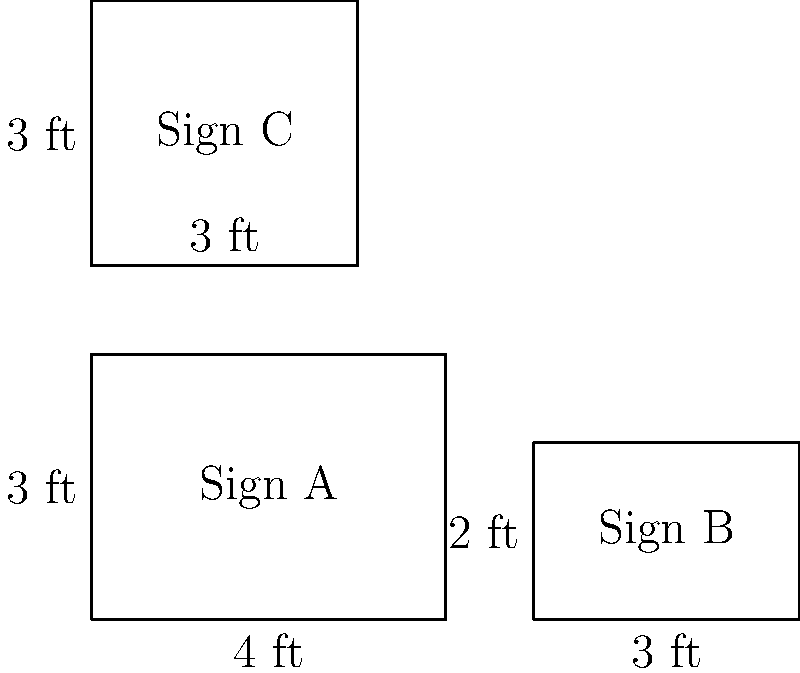You're organizing a campaign to promote traditional family values. You have three rectangular campaign signs with the following dimensions:

Sign A: 4 ft x 3 ft
Sign B: 3 ft x 2 ft
Sign C: 3 ft x 3 ft

What is the total area of all three signs combined? Express your answer in square feet. To find the total area of all three signs, we need to calculate the area of each sign individually and then sum them up.

1. Calculate the area of Sign A:
   $$ \text{Area}_A = \text{length} \times \text{width} = 4 \text{ ft} \times 3 \text{ ft} = 12 \text{ sq ft} $$

2. Calculate the area of Sign B:
   $$ \text{Area}_B = \text{length} \times \text{width} = 3 \text{ ft} \times 2 \text{ ft} = 6 \text{ sq ft} $$

3. Calculate the area of Sign C:
   $$ \text{Area}_C = \text{length} \times \text{width} = 3 \text{ ft} \times 3 \text{ ft} = 9 \text{ sq ft} $$

4. Sum up the areas of all three signs:
   $$ \text{Total Area} = \text{Area}_A + \text{Area}_B + \text{Area}_C $$
   $$ \text{Total Area} = 12 \text{ sq ft} + 6 \text{ sq ft} + 9 \text{ sq ft} = 27 \text{ sq ft} $$

Therefore, the total area of all three campaign signs combined is 27 square feet.
Answer: 27 sq ft 